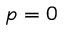Convert formula to latex. <formula><loc_0><loc_0><loc_500><loc_500>p = 0</formula> 